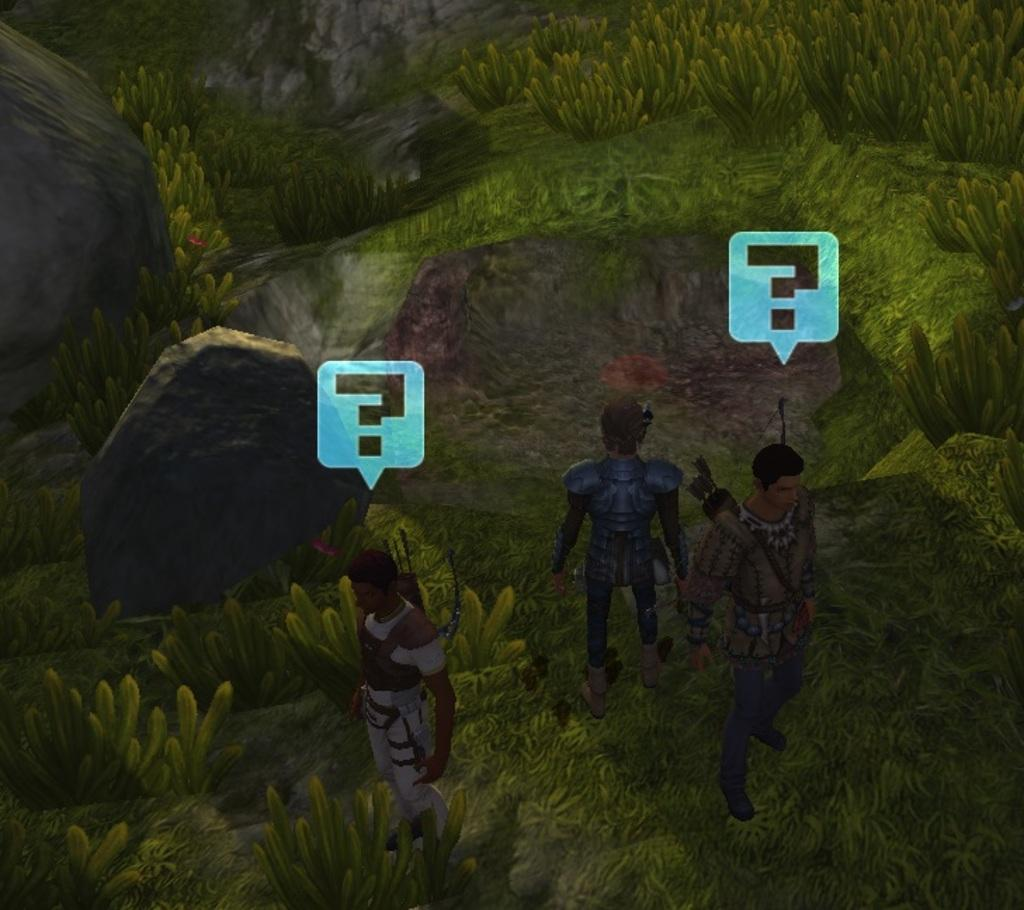What type of picture is in the image? The image contains an animated picture. How many people are present in the image? There are three persons standing in the image. What can be seen in the background of the image? There are rocks visible in the background of the image. What is the color of the plants in the image? The plants in the image are green in color. Can you tell me if the persons in the image are kissing each other? There is no indication in the image that the persons are kissing each other. What time of day is depicted in the image? The time of day is not specified in the image. 